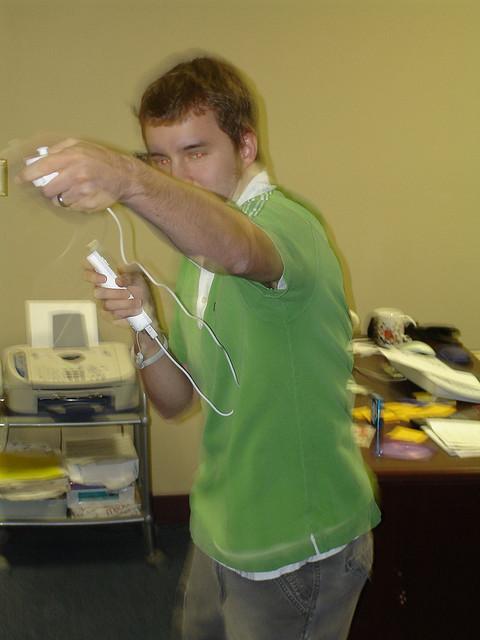Is the picture in focus?
Give a very brief answer. No. What type of technology is the man touching?
Write a very short answer. Wii controller. Which hand is higher than the other?
Write a very short answer. Left. What color is his shirt?
Answer briefly. Green. What game are they playing?
Quick response, please. Wii. 